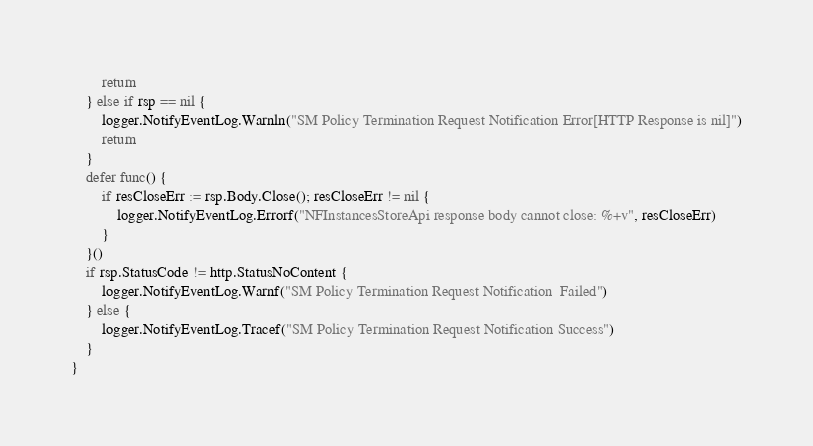Convert code to text. <code><loc_0><loc_0><loc_500><loc_500><_Go_>		return
	} else if rsp == nil {
		logger.NotifyEventLog.Warnln("SM Policy Termination Request Notification Error[HTTP Response is nil]")
		return
	}
	defer func() {
		if resCloseErr := rsp.Body.Close(); resCloseErr != nil {
			logger.NotifyEventLog.Errorf("NFInstancesStoreApi response body cannot close: %+v", resCloseErr)
		}
	}()
	if rsp.StatusCode != http.StatusNoContent {
		logger.NotifyEventLog.Warnf("SM Policy Termination Request Notification  Failed")
	} else {
		logger.NotifyEventLog.Tracef("SM Policy Termination Request Notification Success")
	}
}
</code> 